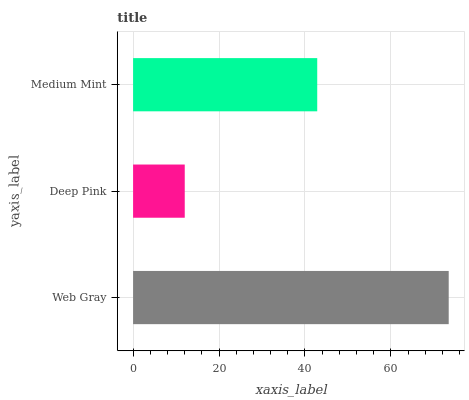Is Deep Pink the minimum?
Answer yes or no. Yes. Is Web Gray the maximum?
Answer yes or no. Yes. Is Medium Mint the minimum?
Answer yes or no. No. Is Medium Mint the maximum?
Answer yes or no. No. Is Medium Mint greater than Deep Pink?
Answer yes or no. Yes. Is Deep Pink less than Medium Mint?
Answer yes or no. Yes. Is Deep Pink greater than Medium Mint?
Answer yes or no. No. Is Medium Mint less than Deep Pink?
Answer yes or no. No. Is Medium Mint the high median?
Answer yes or no. Yes. Is Medium Mint the low median?
Answer yes or no. Yes. Is Web Gray the high median?
Answer yes or no. No. Is Deep Pink the low median?
Answer yes or no. No. 